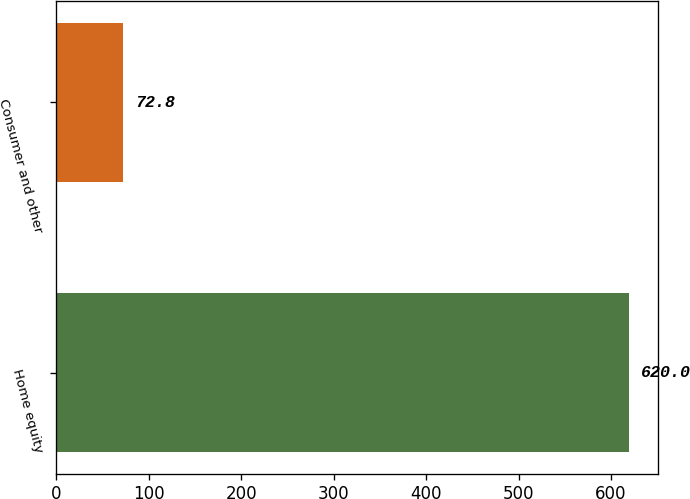<chart> <loc_0><loc_0><loc_500><loc_500><bar_chart><fcel>Home equity<fcel>Consumer and other<nl><fcel>620<fcel>72.8<nl></chart> 